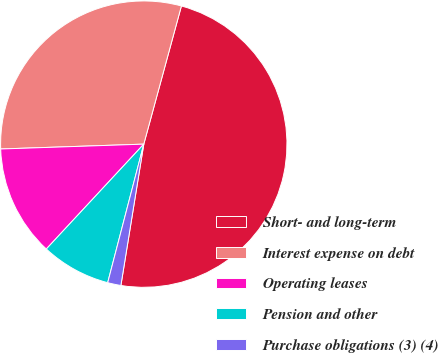<chart> <loc_0><loc_0><loc_500><loc_500><pie_chart><fcel>Short- and long-term<fcel>Interest expense on debt<fcel>Operating leases<fcel>Pension and other<fcel>Purchase obligations (3) (4)<nl><fcel>48.32%<fcel>29.77%<fcel>12.54%<fcel>7.86%<fcel>1.5%<nl></chart> 